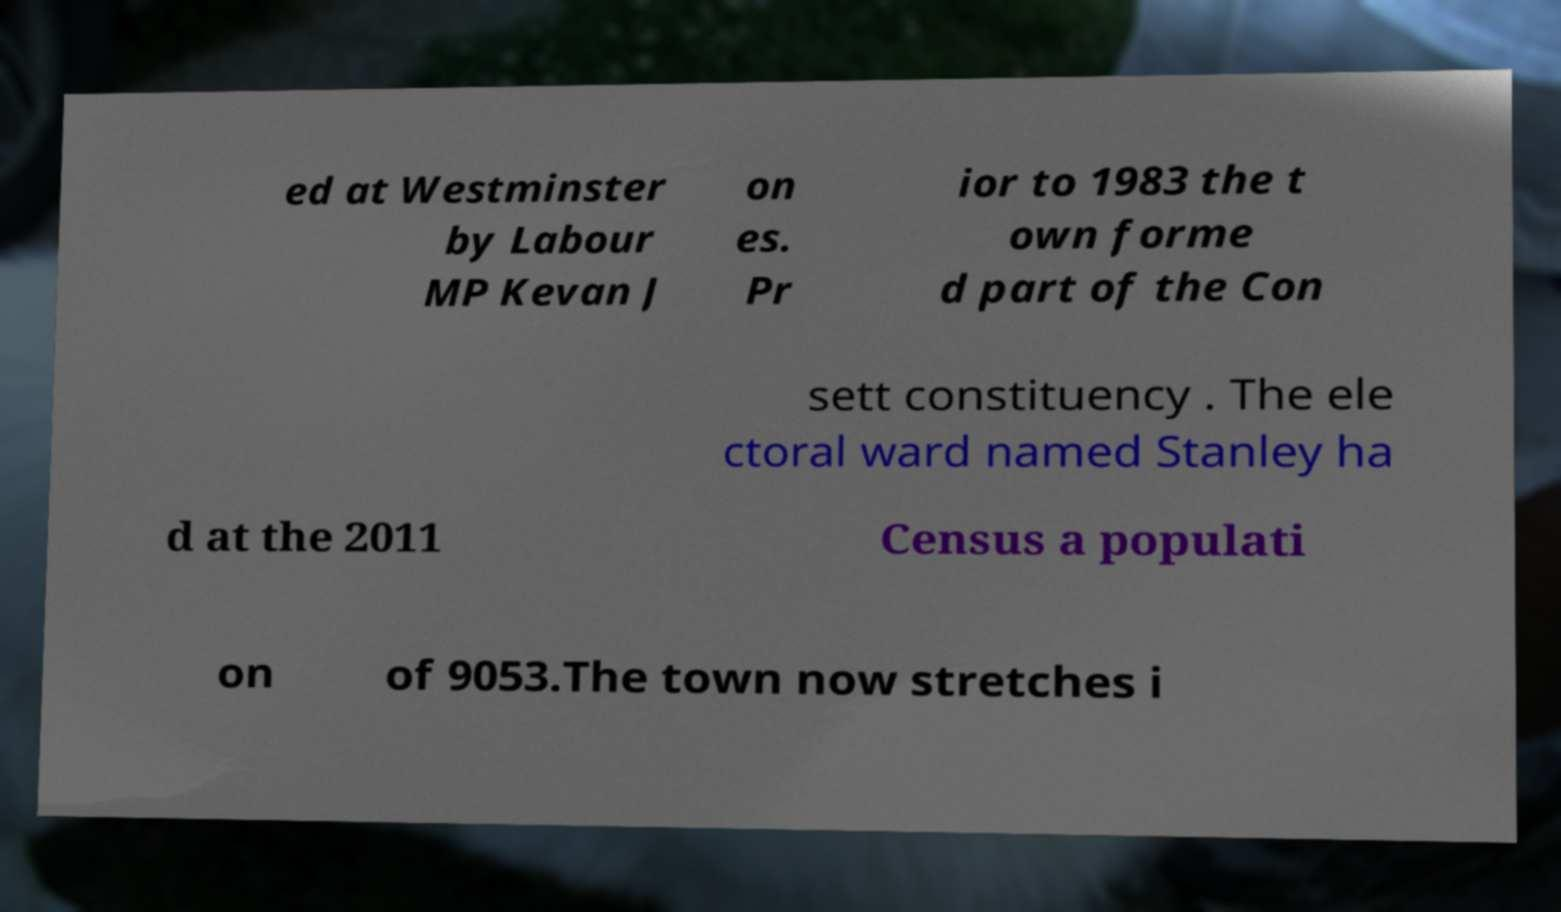Please identify and transcribe the text found in this image. ed at Westminster by Labour MP Kevan J on es. Pr ior to 1983 the t own forme d part of the Con sett constituency . The ele ctoral ward named Stanley ha d at the 2011 Census a populati on of 9053.The town now stretches i 